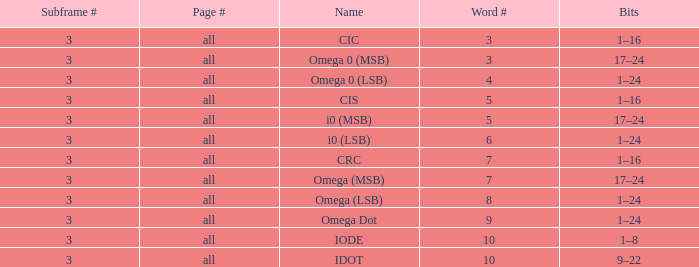What is the total word count with a subframe count greater than 3? None. 